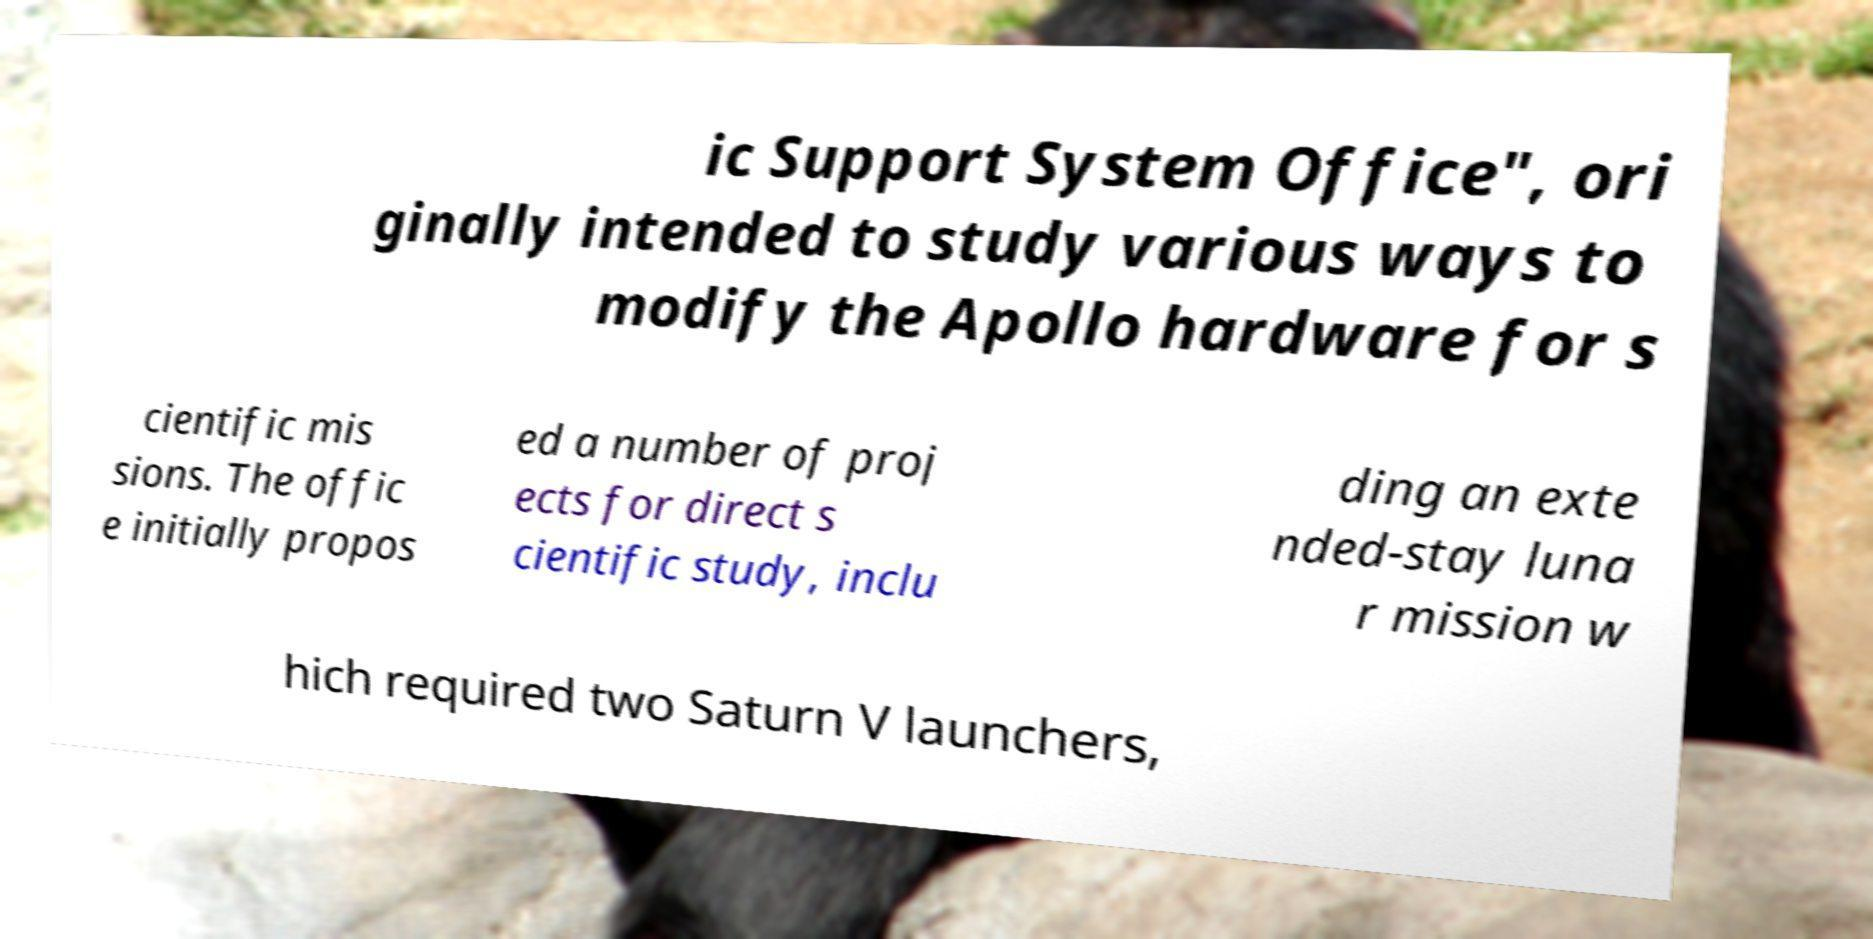Please identify and transcribe the text found in this image. ic Support System Office", ori ginally intended to study various ways to modify the Apollo hardware for s cientific mis sions. The offic e initially propos ed a number of proj ects for direct s cientific study, inclu ding an exte nded-stay luna r mission w hich required two Saturn V launchers, 